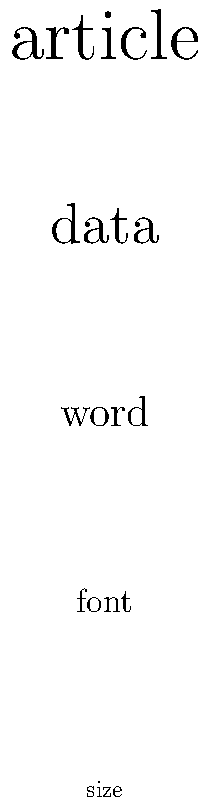In the word cloud visualization above, which word appears to have the highest frequency in the hypothetical article you've written about data visualization techniques? To determine the word with the highest frequency in the visualization:

1. Observe that the words are displayed in different sizes.
2. Understand that in word clouds, larger font sizes typically represent higher frequency words.
3. Compare the sizes of all words present in the visualization.
4. Identify "article" as the largest word in the cloud.
5. Conclude that "article" must be the most frequently used word in the hypothetical written piece.

This visualization technique quickly communicates the relative importance or frequency of words in a text, which is particularly useful for writers and journalists to analyze their own work or summarize content for readers.
Answer: article 